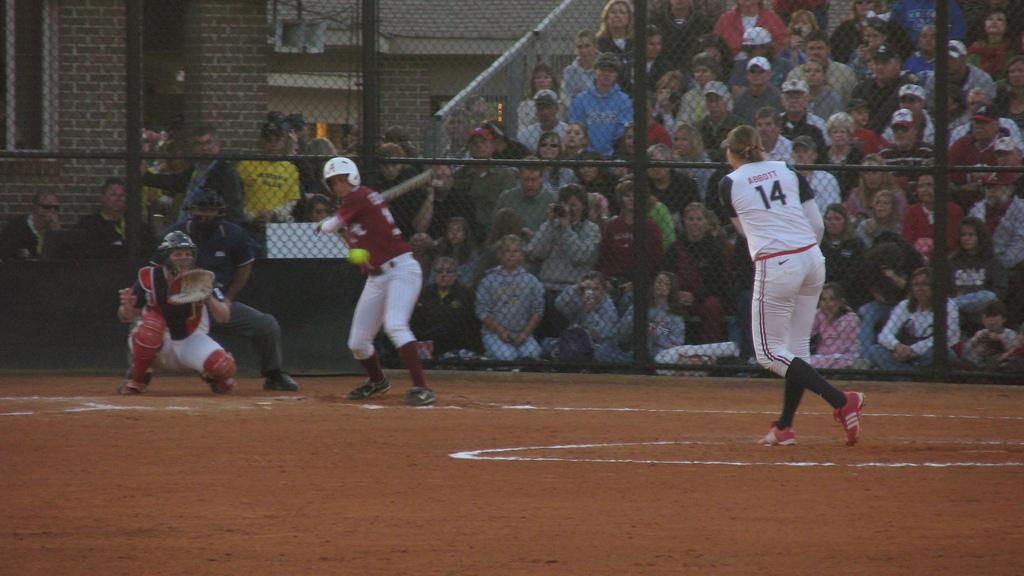<image>
Provide a brief description of the given image. Player number 14 stands at the mound and pitches the ball. 